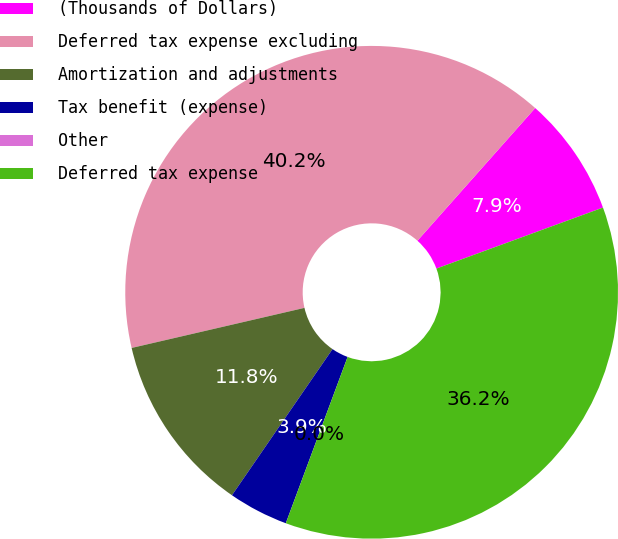Convert chart to OTSL. <chart><loc_0><loc_0><loc_500><loc_500><pie_chart><fcel>(Thousands of Dollars)<fcel>Deferred tax expense excluding<fcel>Amortization and adjustments<fcel>Tax benefit (expense)<fcel>Other<fcel>Deferred tax expense<nl><fcel>7.86%<fcel>40.18%<fcel>11.78%<fcel>3.93%<fcel>0.0%<fcel>36.25%<nl></chart> 